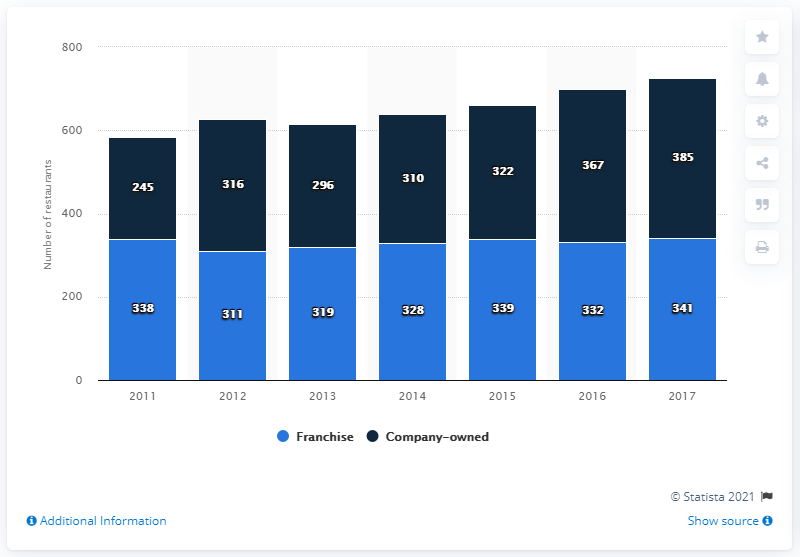Mention a couple of crucial points in this snapshot. Of Qdoba's total number of restaurants, 385 were company-owned. Qdoba Mexican Eats reached its peak in 2017. As of the latest available data, Qdoba had 341 franchised restaurants. 